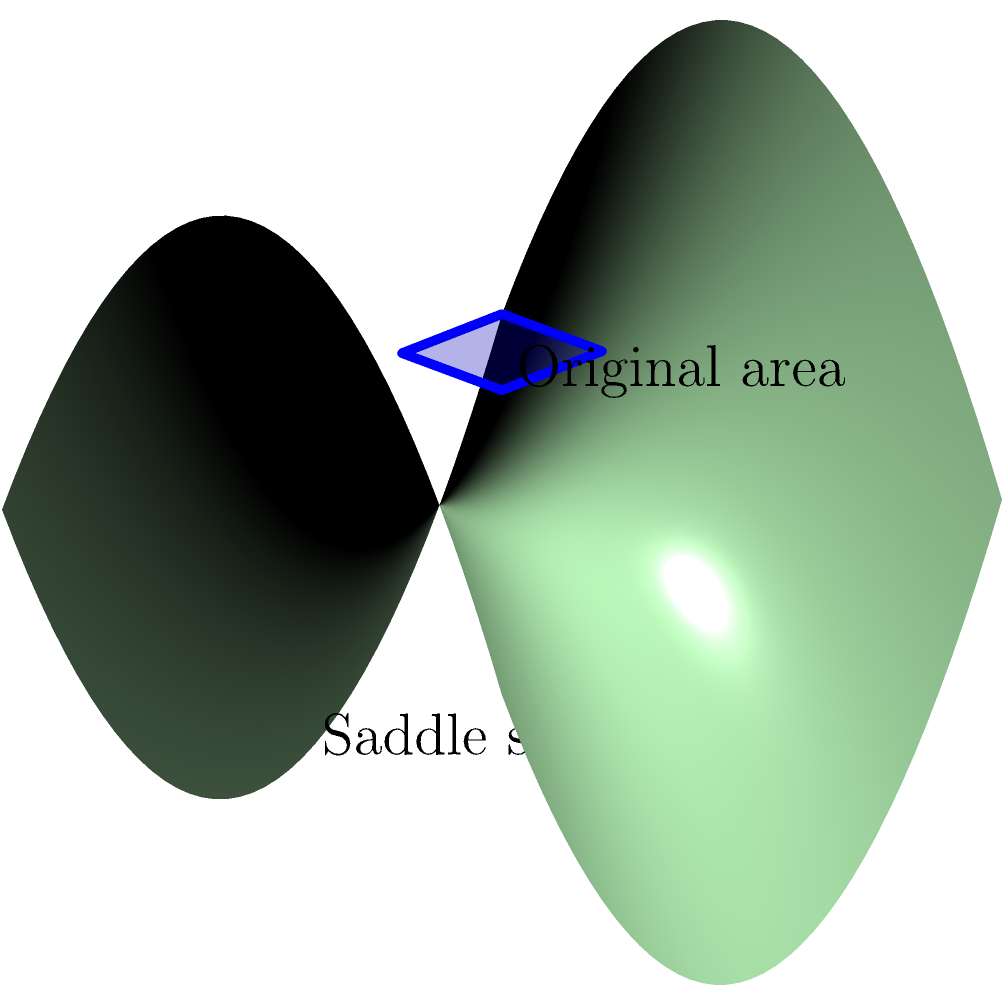In your collaboration with the retired professional golfer, you're discussing how Non-Euclidean Geometry could affect golf course design. If a square-shaped golf course were mapped onto a saddle-shaped surface as shown in the diagram, how would the apparent area of the course change compared to its original flat representation? To understand how the area of the golf course would change when mapped onto a saddle-shaped surface, we need to consider the properties of Non-Euclidean Geometry, specifically hyperbolic geometry:

1. The saddle-shaped surface is an example of a hyperbolic surface, which has negative curvature.

2. In hyperbolic geometry, the sum of the angles in a triangle is less than 180 degrees, unlike in Euclidean geometry where it's exactly 180 degrees.

3. This property leads to an interesting phenomenon: as shapes are mapped onto a hyperbolic surface, they appear to expand.

4. The expansion effect is more pronounced towards the edges of the saddle shape, where the curvature is more extreme.

5. In the diagram, we can see that the square representing the golf course is warped when projected onto the saddle surface.

6. The corners of the square are pulled downward and outward, following the contours of the saddle shape.

7. This warping effect results in an increase in the apparent area of the golf course when viewed from above the saddle surface.

8. The increase in area is not uniform across the entire course. Parts of the course near the center of the saddle (where the curvature is less extreme) will experience less expansion than the parts near the edges.

9. It's important to note that while the apparent area increases, the intrinsic area of the golf course remains the same. This is similar to how a flat map of the Earth distorts the sizes of countries near the poles.

Therefore, when mapped onto a saddle-shaped surface, the golf course would appear larger than its original flat representation, with the extent of enlargement varying across different parts of the course.
Answer: The apparent area would increase. 